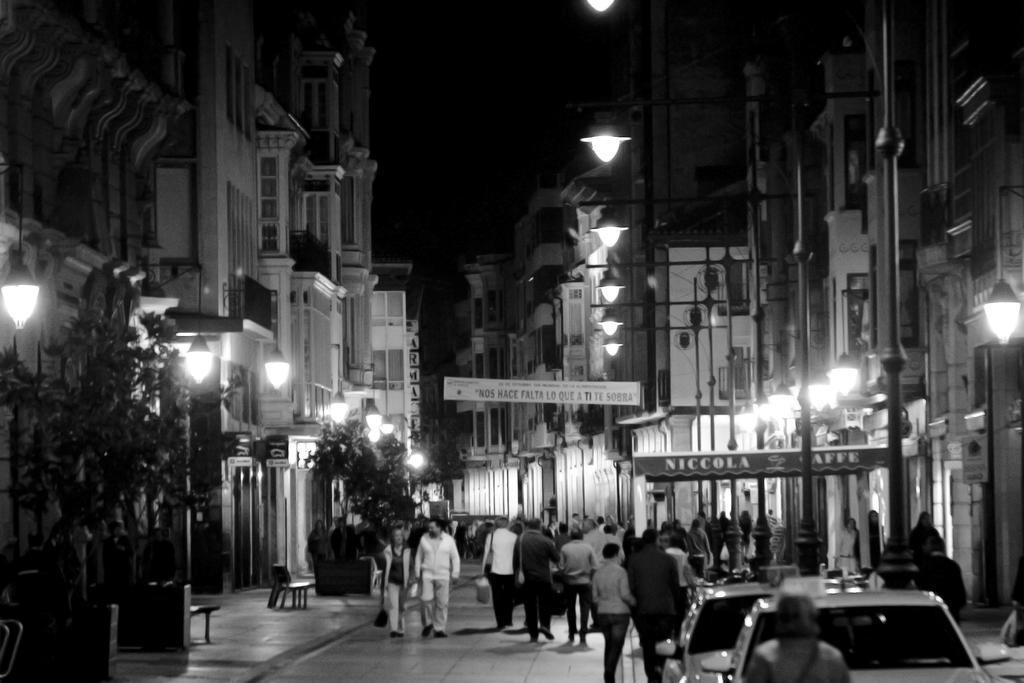Describe this image in one or two sentences. This is a black and white picture with many people walking on the path with buildings on either side of it with trees and street lights in front of it. 